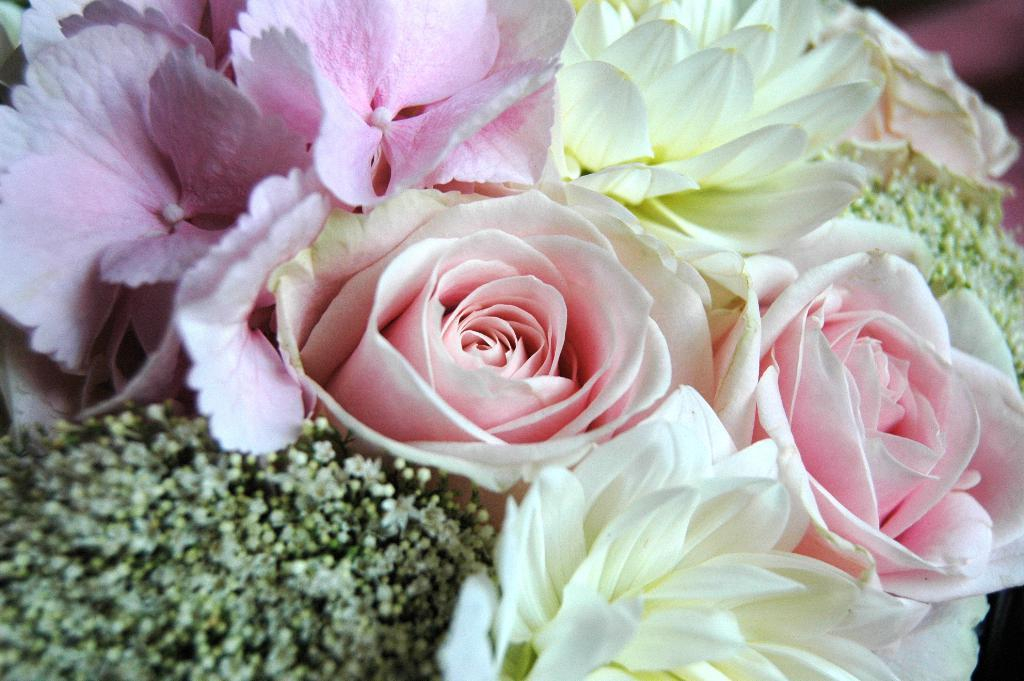What type of living organisms can be seen in the image? There are flowers in the image. Can you describe the appearance of the flowers? The flowers have different colors. What is the condition of the background in the image? The background of the image is blurry. What type of birds can be seen flying in the image? There are no birds present in the image; it features flowers with different colors and a blurry background. How many pins are holding the flowers in the image? There are no pins visible in the image; the flowers are not being held up by any pins. 